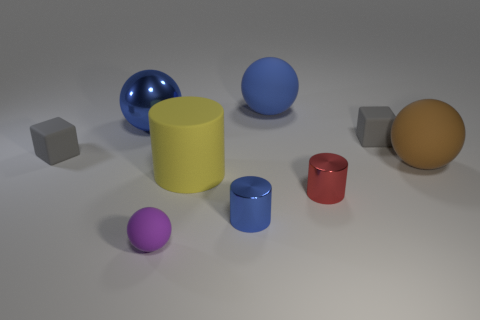What color is the small cylinder that is made of the same material as the red object?
Offer a terse response. Blue. What number of purple matte things have the same size as the blue metal cylinder?
Offer a terse response. 1. Does the ball on the left side of the tiny rubber ball have the same material as the brown sphere?
Your answer should be compact. No. Is the number of purple matte objects behind the tiny blue thing less than the number of tiny cylinders?
Provide a short and direct response. Yes. There is a gray thing that is on the right side of the large yellow rubber cylinder; what is its shape?
Offer a terse response. Cube. The brown matte object that is the same size as the yellow rubber thing is what shape?
Make the answer very short. Sphere. Is there another large matte thing of the same shape as the brown thing?
Make the answer very short. Yes. There is a tiny gray thing right of the small matte sphere; is its shape the same as the gray rubber thing left of the purple thing?
Offer a very short reply. Yes. There is a red cylinder that is the same size as the blue shiny cylinder; what is its material?
Provide a succinct answer. Metal. How many other things are the same material as the big yellow cylinder?
Provide a short and direct response. 5. 